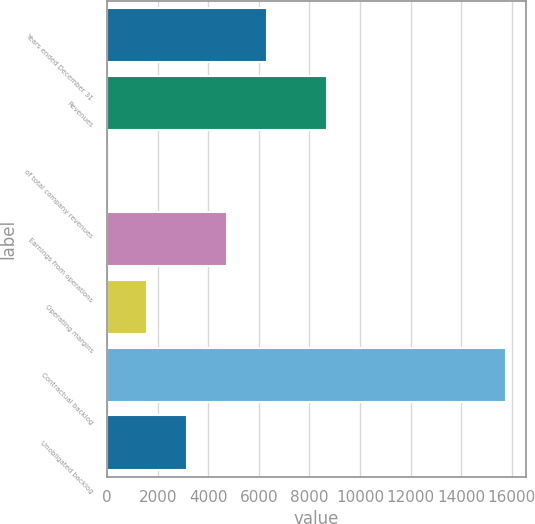Convert chart to OTSL. <chart><loc_0><loc_0><loc_500><loc_500><bar_chart><fcel>Years ended December 31<fcel>Revenues<fcel>of total company revenues<fcel>Earnings from operations<fcel>Operating margins<fcel>Contractual backlog<fcel>Unobligated backlog<nl><fcel>6312.2<fcel>8677<fcel>11<fcel>4736.9<fcel>1586.3<fcel>15764<fcel>3161.6<nl></chart> 